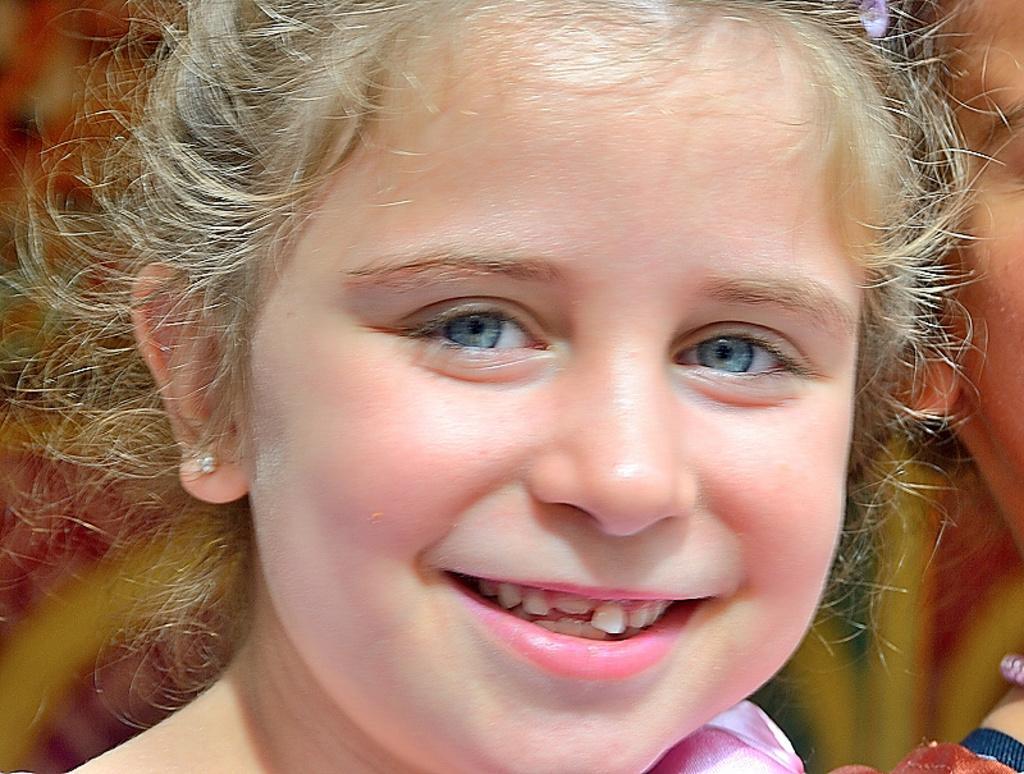Can you describe this image briefly? In this picture we can see a girl smiling. 